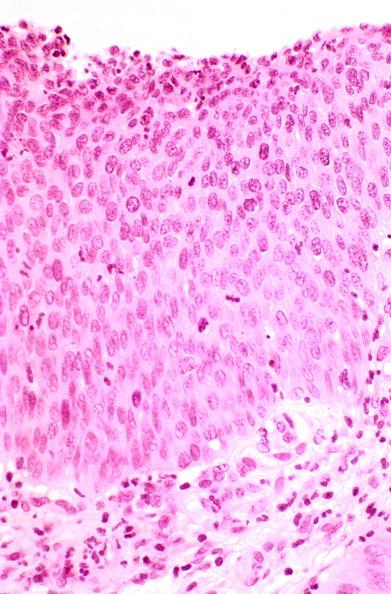s female reproductive present?
Answer the question using a single word or phrase. Yes 